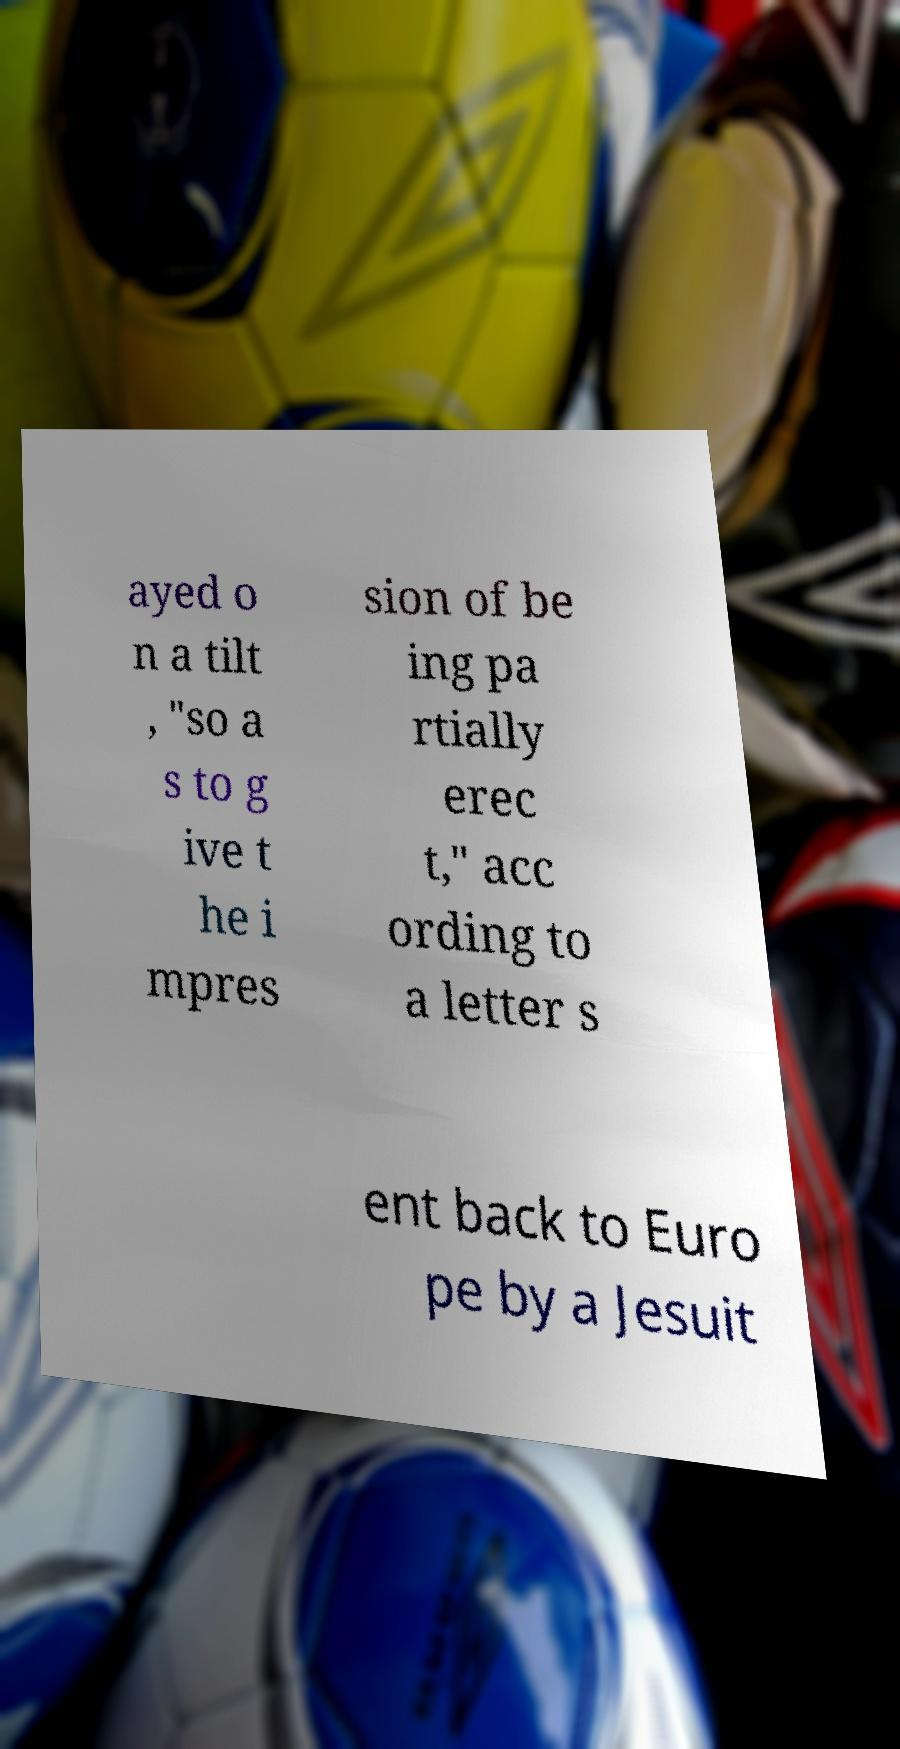Could you assist in decoding the text presented in this image and type it out clearly? ayed o n a tilt , "so a s to g ive t he i mpres sion of be ing pa rtially erec t," acc ording to a letter s ent back to Euro pe by a Jesuit 